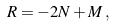Convert formula to latex. <formula><loc_0><loc_0><loc_500><loc_500>R = - 2 N + M \, ,</formula> 